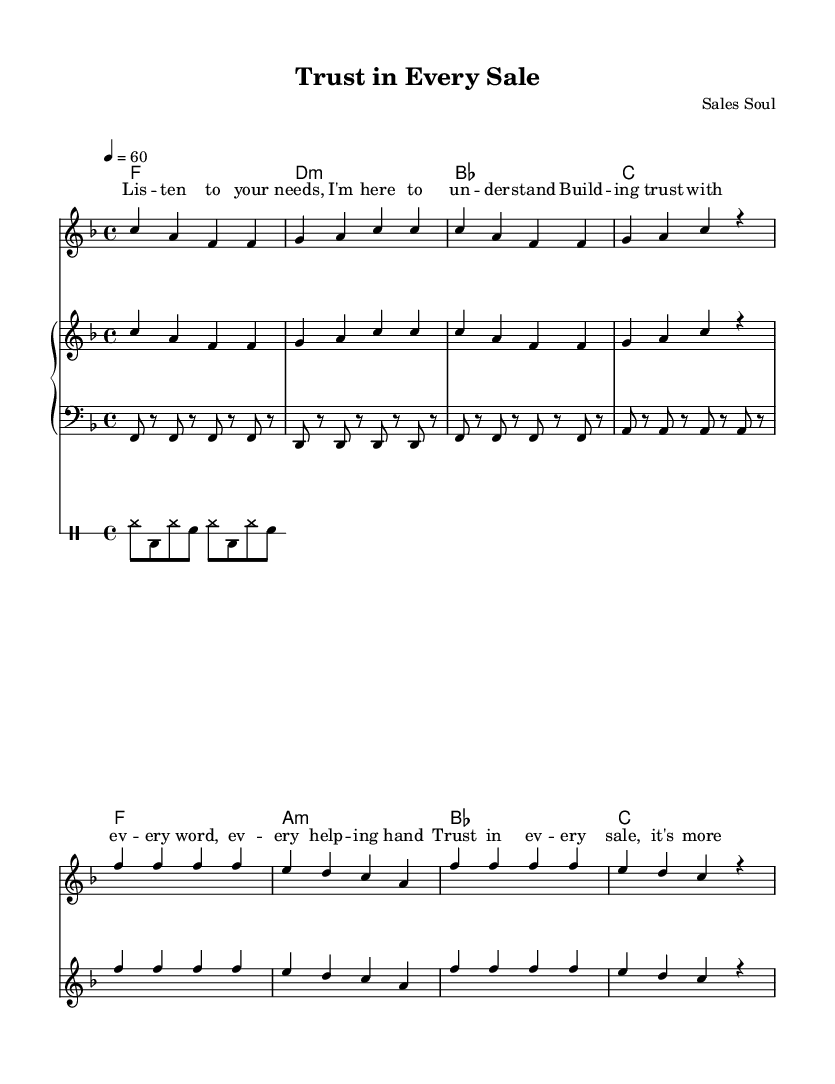What is the key signature of this music? The key signature is F major, which has one flat (B flat). This can be determined by looking at the key signature placement at the beginning of the staff.
Answer: F major What is the time signature of this piece? The time signature is 4/4, indicated at the beginning of the sheet music, which means there are four beats in each measure and the quarter note gets one beat.
Answer: 4/4 What is the tempo marking for this music? The tempo marking is 60, which indicates the speed of the music and means there should be 60 beats per minute. This is seen in the tempo instruction at the beginning of the score.
Answer: 60 How many measures are in the verse section? The verse section consists of four measures, which can be counted from the notation shown in the melody part, specifically the first part of the song labeled under the verse.
Answer: 4 Which chord is played in the chorus? The chorus features the chords F major, A minor, B flat, and C major. These are determined from the chord symbols written above the staff during the chorus part.
Answer: F, A minor, B flat, C What is the lyrical theme of the song? The lyrical theme of the song revolves around customer relationships and building trust, which is reflected in the lyrics provided below the melody. This captures the essence of smooth R&B soul ballads in addressing customer satisfaction.
Answer: Customer relationships and trust How is the bass part indicated in the sheet music? The bass part is indicated using a clef called the bass clef, placed at the beginning of the staff for the bass notes, which shows that it plays lower pitches. The specific notes are written in the appropriate bass clef notation.
Answer: Bass clef 